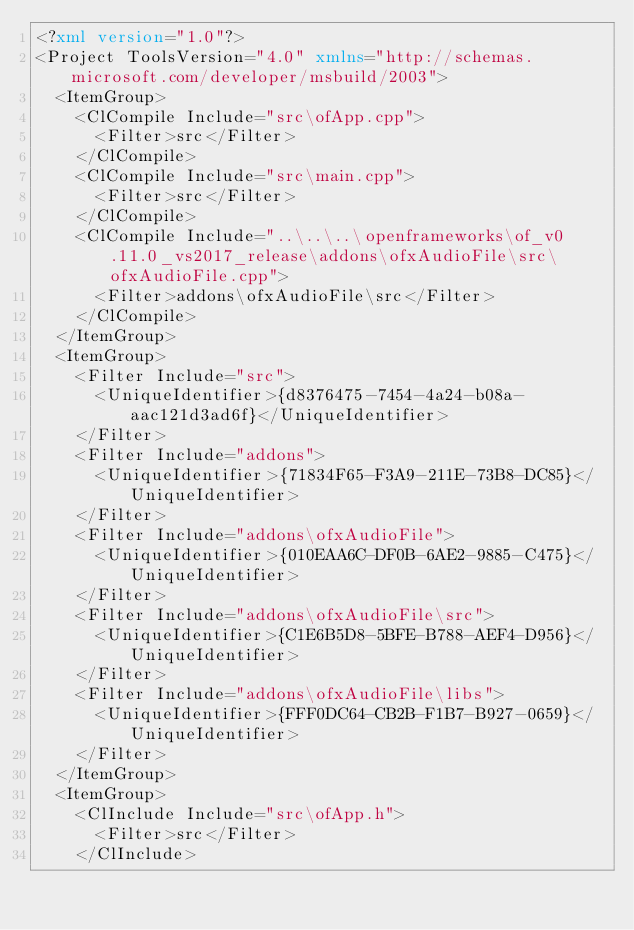<code> <loc_0><loc_0><loc_500><loc_500><_XML_><?xml version="1.0"?>
<Project ToolsVersion="4.0" xmlns="http://schemas.microsoft.com/developer/msbuild/2003">
	<ItemGroup>
		<ClCompile Include="src\ofApp.cpp">
			<Filter>src</Filter>
		</ClCompile>
		<ClCompile Include="src\main.cpp">
			<Filter>src</Filter>
		</ClCompile>
		<ClCompile Include="..\..\..\openframeworks\of_v0.11.0_vs2017_release\addons\ofxAudioFile\src\ofxAudioFile.cpp">
			<Filter>addons\ofxAudioFile\src</Filter>
		</ClCompile>
	</ItemGroup>
	<ItemGroup>
		<Filter Include="src">
			<UniqueIdentifier>{d8376475-7454-4a24-b08a-aac121d3ad6f}</UniqueIdentifier>
		</Filter>
		<Filter Include="addons">
			<UniqueIdentifier>{71834F65-F3A9-211E-73B8-DC85}</UniqueIdentifier>
		</Filter>
		<Filter Include="addons\ofxAudioFile">
			<UniqueIdentifier>{010EAA6C-DF0B-6AE2-9885-C475}</UniqueIdentifier>
		</Filter>
		<Filter Include="addons\ofxAudioFile\src">
			<UniqueIdentifier>{C1E6B5D8-5BFE-B788-AEF4-D956}</UniqueIdentifier>
		</Filter>
		<Filter Include="addons\ofxAudioFile\libs">
			<UniqueIdentifier>{FFF0DC64-CB2B-F1B7-B927-0659}</UniqueIdentifier>
		</Filter>
	</ItemGroup>
	<ItemGroup>
		<ClInclude Include="src\ofApp.h">
			<Filter>src</Filter>
		</ClInclude></code> 